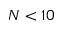Convert formula to latex. <formula><loc_0><loc_0><loc_500><loc_500>N < 1 0</formula> 